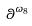Convert formula to latex. <formula><loc_0><loc_0><loc_500><loc_500>\theta ^ { \omega _ { 8 } }</formula> 